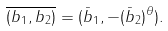Convert formula to latex. <formula><loc_0><loc_0><loc_500><loc_500>\overline { ( b _ { 1 } , b _ { 2 } ) } = ( \bar { b } _ { 1 } , - ( \bar { b } _ { 2 } ) ^ { \theta } ) .</formula> 